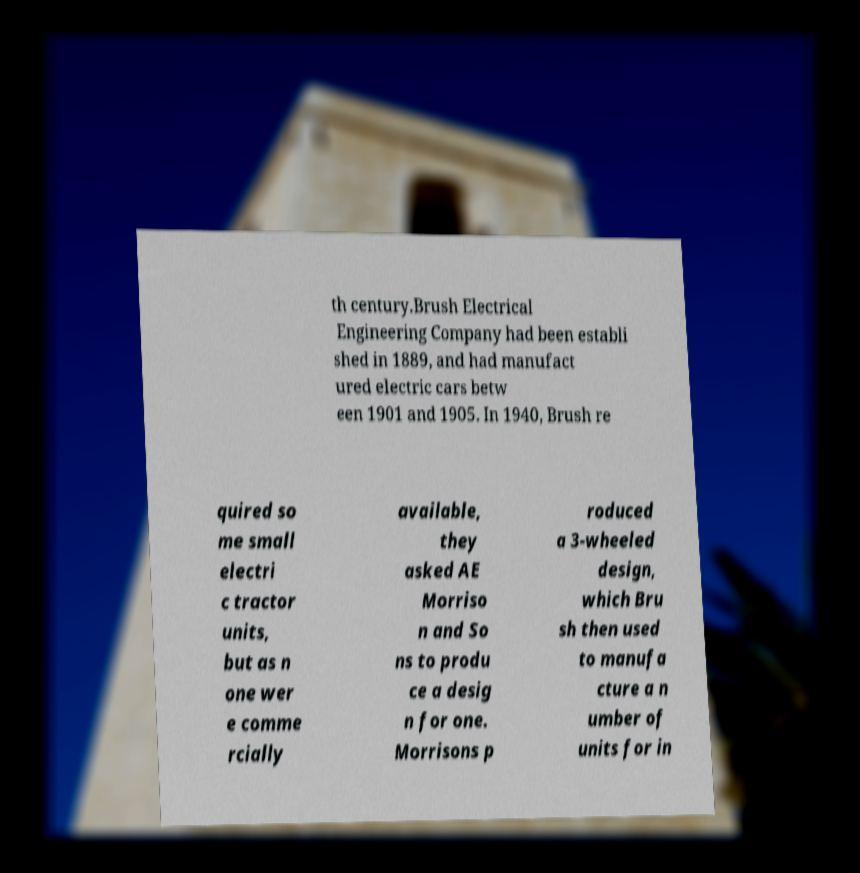For documentation purposes, I need the text within this image transcribed. Could you provide that? th century.Brush Electrical Engineering Company had been establi shed in 1889, and had manufact ured electric cars betw een 1901 and 1905. In 1940, Brush re quired so me small electri c tractor units, but as n one wer e comme rcially available, they asked AE Morriso n and So ns to produ ce a desig n for one. Morrisons p roduced a 3-wheeled design, which Bru sh then used to manufa cture a n umber of units for in 